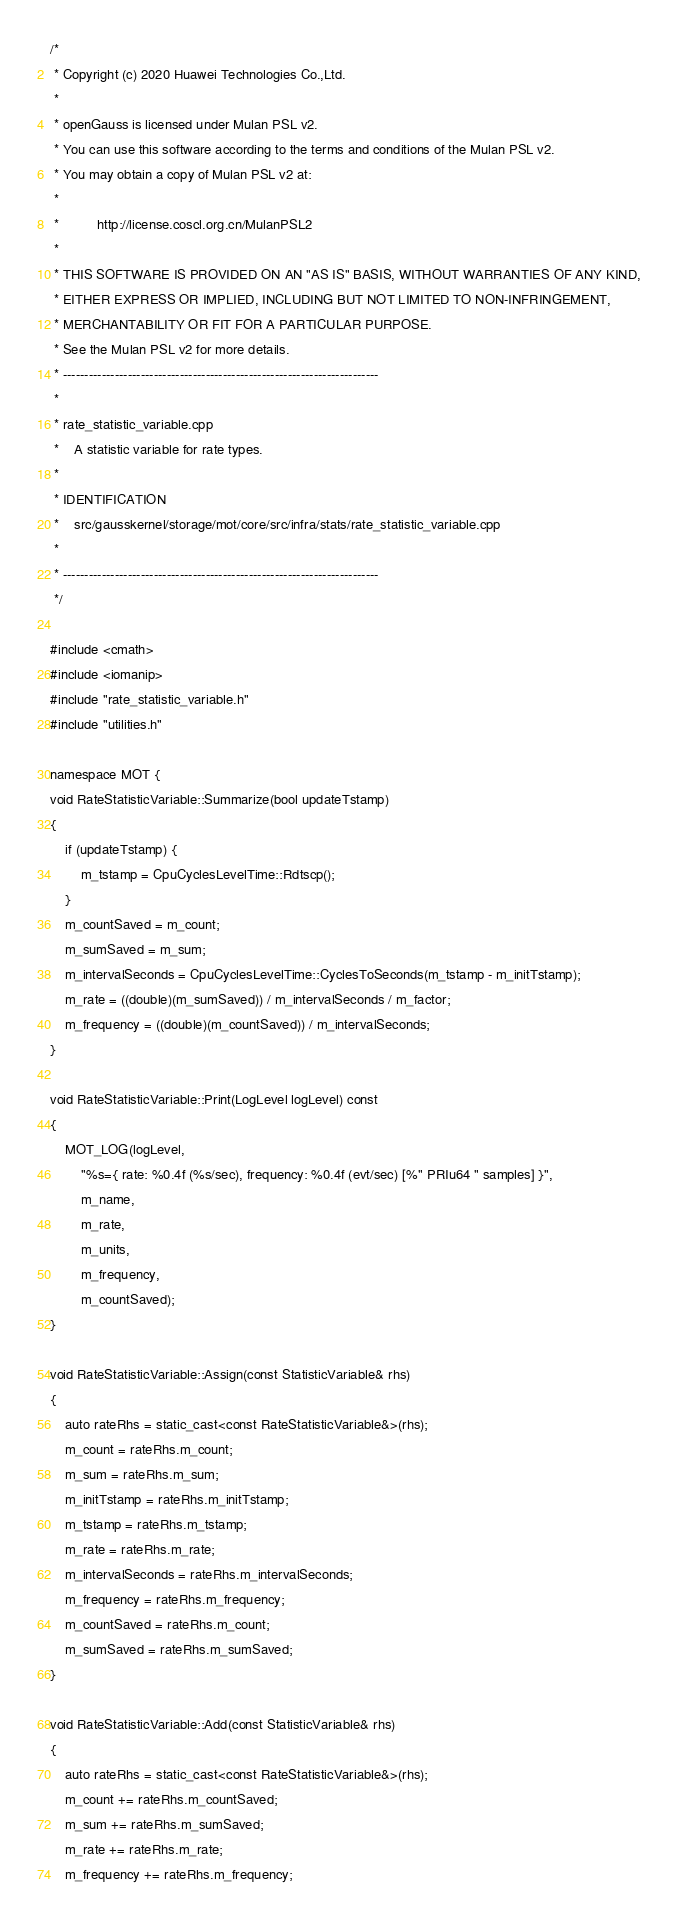<code> <loc_0><loc_0><loc_500><loc_500><_C++_>/*
 * Copyright (c) 2020 Huawei Technologies Co.,Ltd.
 *
 * openGauss is licensed under Mulan PSL v2.
 * You can use this software according to the terms and conditions of the Mulan PSL v2.
 * You may obtain a copy of Mulan PSL v2 at:
 *
 *          http://license.coscl.org.cn/MulanPSL2
 *
 * THIS SOFTWARE IS PROVIDED ON AN "AS IS" BASIS, WITHOUT WARRANTIES OF ANY KIND,
 * EITHER EXPRESS OR IMPLIED, INCLUDING BUT NOT LIMITED TO NON-INFRINGEMENT,
 * MERCHANTABILITY OR FIT FOR A PARTICULAR PURPOSE.
 * See the Mulan PSL v2 for more details.
 * -------------------------------------------------------------------------
 *
 * rate_statistic_variable.cpp
 *    A statistic variable for rate types.
 *
 * IDENTIFICATION
 *    src/gausskernel/storage/mot/core/src/infra/stats/rate_statistic_variable.cpp
 *
 * -------------------------------------------------------------------------
 */

#include <cmath>
#include <iomanip>
#include "rate_statistic_variable.h"
#include "utilities.h"

namespace MOT {
void RateStatisticVariable::Summarize(bool updateTstamp)
{
    if (updateTstamp) {
        m_tstamp = CpuCyclesLevelTime::Rdtscp();
    }
    m_countSaved = m_count;
    m_sumSaved = m_sum;
    m_intervalSeconds = CpuCyclesLevelTime::CyclesToSeconds(m_tstamp - m_initTstamp);
    m_rate = ((double)(m_sumSaved)) / m_intervalSeconds / m_factor;
    m_frequency = ((double)(m_countSaved)) / m_intervalSeconds;
}

void RateStatisticVariable::Print(LogLevel logLevel) const
{
    MOT_LOG(logLevel,
        "%s={ rate: %0.4f (%s/sec), frequency: %0.4f (evt/sec) [%" PRIu64 " samples] }",
        m_name,
        m_rate,
        m_units,
        m_frequency,
        m_countSaved);
}

void RateStatisticVariable::Assign(const StatisticVariable& rhs)
{
    auto rateRhs = static_cast<const RateStatisticVariable&>(rhs);
    m_count = rateRhs.m_count;
    m_sum = rateRhs.m_sum;
    m_initTstamp = rateRhs.m_initTstamp;
    m_tstamp = rateRhs.m_tstamp;
    m_rate = rateRhs.m_rate;
    m_intervalSeconds = rateRhs.m_intervalSeconds;
    m_frequency = rateRhs.m_frequency;
    m_countSaved = rateRhs.m_count;
    m_sumSaved = rateRhs.m_sumSaved;
}

void RateStatisticVariable::Add(const StatisticVariable& rhs)
{
    auto rateRhs = static_cast<const RateStatisticVariable&>(rhs);
    m_count += rateRhs.m_countSaved;
    m_sum += rateRhs.m_sumSaved;
    m_rate += rateRhs.m_rate;
    m_frequency += rateRhs.m_frequency;</code> 